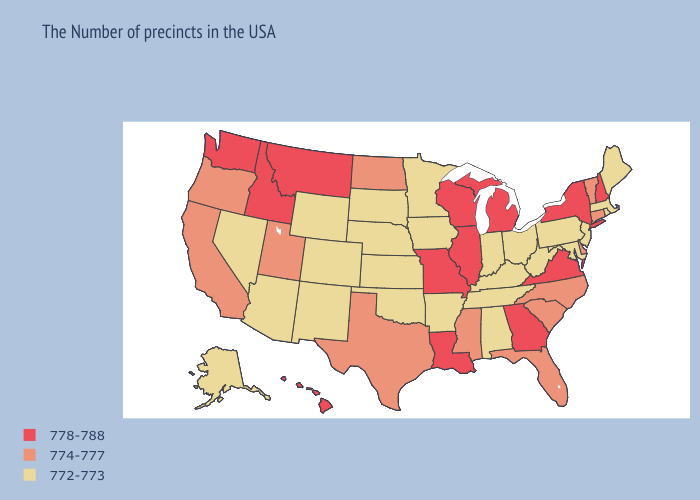What is the highest value in states that border Kentucky?
Short answer required. 778-788. Among the states that border Wyoming , does Nebraska have the highest value?
Concise answer only. No. Does Georgia have the highest value in the USA?
Quick response, please. Yes. Name the states that have a value in the range 778-788?
Answer briefly. New Hampshire, New York, Virginia, Georgia, Michigan, Wisconsin, Illinois, Louisiana, Missouri, Montana, Idaho, Washington, Hawaii. Does Arizona have a higher value than Oklahoma?
Answer briefly. No. What is the lowest value in states that border Rhode Island?
Short answer required. 772-773. Does Virginia have the lowest value in the USA?
Answer briefly. No. Does the first symbol in the legend represent the smallest category?
Write a very short answer. No. Does the map have missing data?
Answer briefly. No. Which states hav the highest value in the MidWest?
Quick response, please. Michigan, Wisconsin, Illinois, Missouri. Does Illinois have the lowest value in the USA?
Answer briefly. No. Name the states that have a value in the range 774-777?
Quick response, please. Vermont, Connecticut, Delaware, North Carolina, South Carolina, Florida, Mississippi, Texas, North Dakota, Utah, California, Oregon. Name the states that have a value in the range 778-788?
Give a very brief answer. New Hampshire, New York, Virginia, Georgia, Michigan, Wisconsin, Illinois, Louisiana, Missouri, Montana, Idaho, Washington, Hawaii. What is the value of North Dakota?
Be succinct. 774-777. Does Alaska have a lower value than Colorado?
Short answer required. No. 